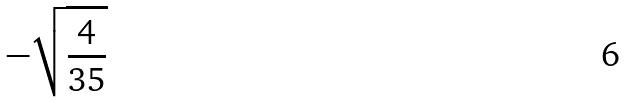Convert formula to latex. <formula><loc_0><loc_0><loc_500><loc_500>- \sqrt { \frac { 4 } { 3 5 } }</formula> 